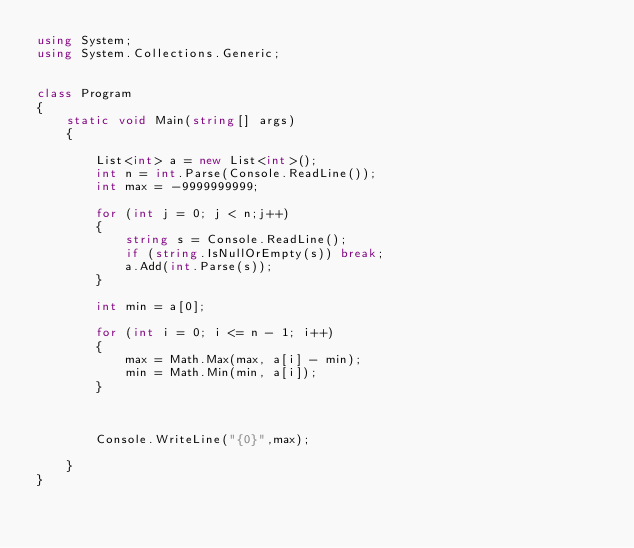<code> <loc_0><loc_0><loc_500><loc_500><_C#_>using System;
using System.Collections.Generic;


class Program
{
    static void Main(string[] args)
    {

        List<int> a = new List<int>();
        int n = int.Parse(Console.ReadLine());
        int max = -9999999999;

        for (int j = 0; j < n;j++)
        {
            string s = Console.ReadLine();
            if (string.IsNullOrEmpty(s)) break;
            a.Add(int.Parse(s));
        }

        int min = a[0];

		for (int i = 0; i <= n - 1; i++)
		{
			max = Math.Max(max, a[i] - min);
			min = Math.Min(min, a[i]);
		}



        Console.WriteLine("{0}",max);

	}
}</code> 